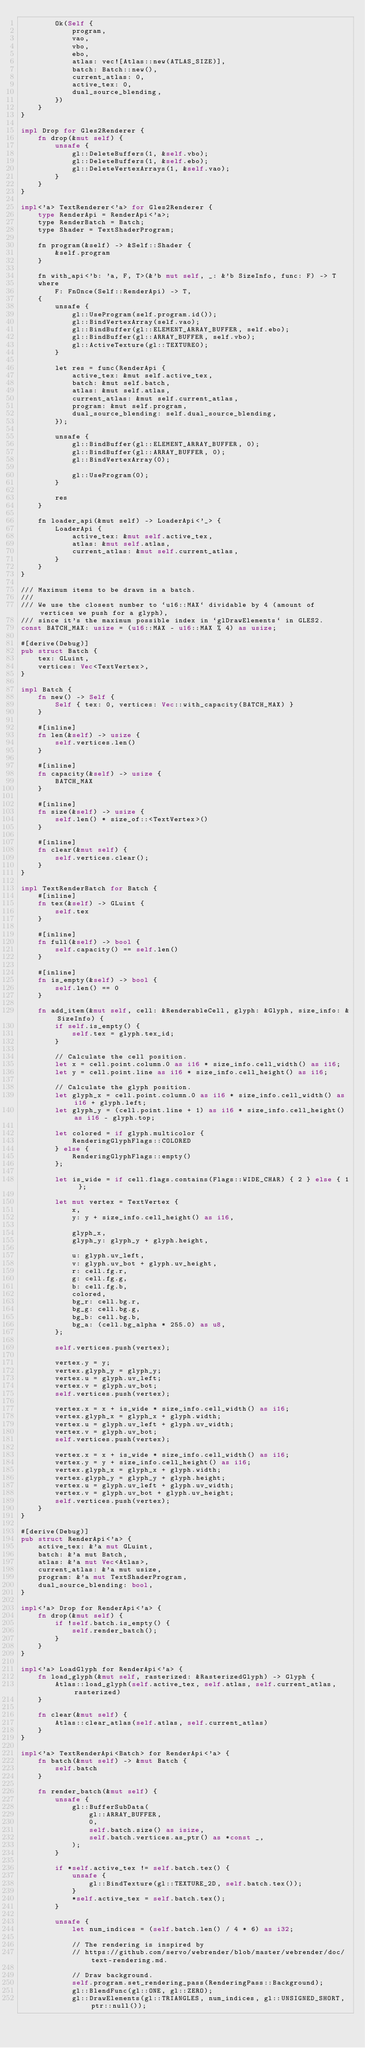Convert code to text. <code><loc_0><loc_0><loc_500><loc_500><_Rust_>        Ok(Self {
            program,
            vao,
            vbo,
            ebo,
            atlas: vec![Atlas::new(ATLAS_SIZE)],
            batch: Batch::new(),
            current_atlas: 0,
            active_tex: 0,
            dual_source_blending,
        })
    }
}

impl Drop for Gles2Renderer {
    fn drop(&mut self) {
        unsafe {
            gl::DeleteBuffers(1, &self.vbo);
            gl::DeleteBuffers(1, &self.ebo);
            gl::DeleteVertexArrays(1, &self.vao);
        }
    }
}

impl<'a> TextRenderer<'a> for Gles2Renderer {
    type RenderApi = RenderApi<'a>;
    type RenderBatch = Batch;
    type Shader = TextShaderProgram;

    fn program(&self) -> &Self::Shader {
        &self.program
    }

    fn with_api<'b: 'a, F, T>(&'b mut self, _: &'b SizeInfo, func: F) -> T
    where
        F: FnOnce(Self::RenderApi) -> T,
    {
        unsafe {
            gl::UseProgram(self.program.id());
            gl::BindVertexArray(self.vao);
            gl::BindBuffer(gl::ELEMENT_ARRAY_BUFFER, self.ebo);
            gl::BindBuffer(gl::ARRAY_BUFFER, self.vbo);
            gl::ActiveTexture(gl::TEXTURE0);
        }

        let res = func(RenderApi {
            active_tex: &mut self.active_tex,
            batch: &mut self.batch,
            atlas: &mut self.atlas,
            current_atlas: &mut self.current_atlas,
            program: &mut self.program,
            dual_source_blending: self.dual_source_blending,
        });

        unsafe {
            gl::BindBuffer(gl::ELEMENT_ARRAY_BUFFER, 0);
            gl::BindBuffer(gl::ARRAY_BUFFER, 0);
            gl::BindVertexArray(0);

            gl::UseProgram(0);
        }

        res
    }

    fn loader_api(&mut self) -> LoaderApi<'_> {
        LoaderApi {
            active_tex: &mut self.active_tex,
            atlas: &mut self.atlas,
            current_atlas: &mut self.current_atlas,
        }
    }
}

/// Maximum items to be drawn in a batch.
///
/// We use the closest number to `u16::MAX` dividable by 4 (amount of vertices we push for a glyph),
/// since it's the maximum possible index in `glDrawElements` in GLES2.
const BATCH_MAX: usize = (u16::MAX - u16::MAX % 4) as usize;

#[derive(Debug)]
pub struct Batch {
    tex: GLuint,
    vertices: Vec<TextVertex>,
}

impl Batch {
    fn new() -> Self {
        Self { tex: 0, vertices: Vec::with_capacity(BATCH_MAX) }
    }

    #[inline]
    fn len(&self) -> usize {
        self.vertices.len()
    }

    #[inline]
    fn capacity(&self) -> usize {
        BATCH_MAX
    }

    #[inline]
    fn size(&self) -> usize {
        self.len() * size_of::<TextVertex>()
    }

    #[inline]
    fn clear(&mut self) {
        self.vertices.clear();
    }
}

impl TextRenderBatch for Batch {
    #[inline]
    fn tex(&self) -> GLuint {
        self.tex
    }

    #[inline]
    fn full(&self) -> bool {
        self.capacity() == self.len()
    }

    #[inline]
    fn is_empty(&self) -> bool {
        self.len() == 0
    }

    fn add_item(&mut self, cell: &RenderableCell, glyph: &Glyph, size_info: &SizeInfo) {
        if self.is_empty() {
            self.tex = glyph.tex_id;
        }

        // Calculate the cell position.
        let x = cell.point.column.0 as i16 * size_info.cell_width() as i16;
        let y = cell.point.line as i16 * size_info.cell_height() as i16;

        // Calculate the glyph position.
        let glyph_x = cell.point.column.0 as i16 * size_info.cell_width() as i16 + glyph.left;
        let glyph_y = (cell.point.line + 1) as i16 * size_info.cell_height() as i16 - glyph.top;

        let colored = if glyph.multicolor {
            RenderingGlyphFlags::COLORED
        } else {
            RenderingGlyphFlags::empty()
        };

        let is_wide = if cell.flags.contains(Flags::WIDE_CHAR) { 2 } else { 1 };

        let mut vertex = TextVertex {
            x,
            y: y + size_info.cell_height() as i16,

            glyph_x,
            glyph_y: glyph_y + glyph.height,

            u: glyph.uv_left,
            v: glyph.uv_bot + glyph.uv_height,
            r: cell.fg.r,
            g: cell.fg.g,
            b: cell.fg.b,
            colored,
            bg_r: cell.bg.r,
            bg_g: cell.bg.g,
            bg_b: cell.bg.b,
            bg_a: (cell.bg_alpha * 255.0) as u8,
        };

        self.vertices.push(vertex);

        vertex.y = y;
        vertex.glyph_y = glyph_y;
        vertex.u = glyph.uv_left;
        vertex.v = glyph.uv_bot;
        self.vertices.push(vertex);

        vertex.x = x + is_wide * size_info.cell_width() as i16;
        vertex.glyph_x = glyph_x + glyph.width;
        vertex.u = glyph.uv_left + glyph.uv_width;
        vertex.v = glyph.uv_bot;
        self.vertices.push(vertex);

        vertex.x = x + is_wide * size_info.cell_width() as i16;
        vertex.y = y + size_info.cell_height() as i16;
        vertex.glyph_x = glyph_x + glyph.width;
        vertex.glyph_y = glyph_y + glyph.height;
        vertex.u = glyph.uv_left + glyph.uv_width;
        vertex.v = glyph.uv_bot + glyph.uv_height;
        self.vertices.push(vertex);
    }
}

#[derive(Debug)]
pub struct RenderApi<'a> {
    active_tex: &'a mut GLuint,
    batch: &'a mut Batch,
    atlas: &'a mut Vec<Atlas>,
    current_atlas: &'a mut usize,
    program: &'a mut TextShaderProgram,
    dual_source_blending: bool,
}

impl<'a> Drop for RenderApi<'a> {
    fn drop(&mut self) {
        if !self.batch.is_empty() {
            self.render_batch();
        }
    }
}

impl<'a> LoadGlyph for RenderApi<'a> {
    fn load_glyph(&mut self, rasterized: &RasterizedGlyph) -> Glyph {
        Atlas::load_glyph(self.active_tex, self.atlas, self.current_atlas, rasterized)
    }

    fn clear(&mut self) {
        Atlas::clear_atlas(self.atlas, self.current_atlas)
    }
}

impl<'a> TextRenderApi<Batch> for RenderApi<'a> {
    fn batch(&mut self) -> &mut Batch {
        self.batch
    }

    fn render_batch(&mut self) {
        unsafe {
            gl::BufferSubData(
                gl::ARRAY_BUFFER,
                0,
                self.batch.size() as isize,
                self.batch.vertices.as_ptr() as *const _,
            );
        }

        if *self.active_tex != self.batch.tex() {
            unsafe {
                gl::BindTexture(gl::TEXTURE_2D, self.batch.tex());
            }
            *self.active_tex = self.batch.tex();
        }

        unsafe {
            let num_indices = (self.batch.len() / 4 * 6) as i32;

            // The rendering is inspired by
            // https://github.com/servo/webrender/blob/master/webrender/doc/text-rendering.md.

            // Draw background.
            self.program.set_rendering_pass(RenderingPass::Background);
            gl::BlendFunc(gl::ONE, gl::ZERO);
            gl::DrawElements(gl::TRIANGLES, num_indices, gl::UNSIGNED_SHORT, ptr::null());
</code> 